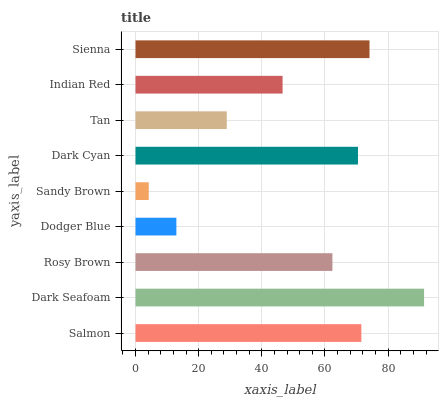Is Sandy Brown the minimum?
Answer yes or no. Yes. Is Dark Seafoam the maximum?
Answer yes or no. Yes. Is Rosy Brown the minimum?
Answer yes or no. No. Is Rosy Brown the maximum?
Answer yes or no. No. Is Dark Seafoam greater than Rosy Brown?
Answer yes or no. Yes. Is Rosy Brown less than Dark Seafoam?
Answer yes or no. Yes. Is Rosy Brown greater than Dark Seafoam?
Answer yes or no. No. Is Dark Seafoam less than Rosy Brown?
Answer yes or no. No. Is Rosy Brown the high median?
Answer yes or no. Yes. Is Rosy Brown the low median?
Answer yes or no. Yes. Is Dodger Blue the high median?
Answer yes or no. No. Is Tan the low median?
Answer yes or no. No. 